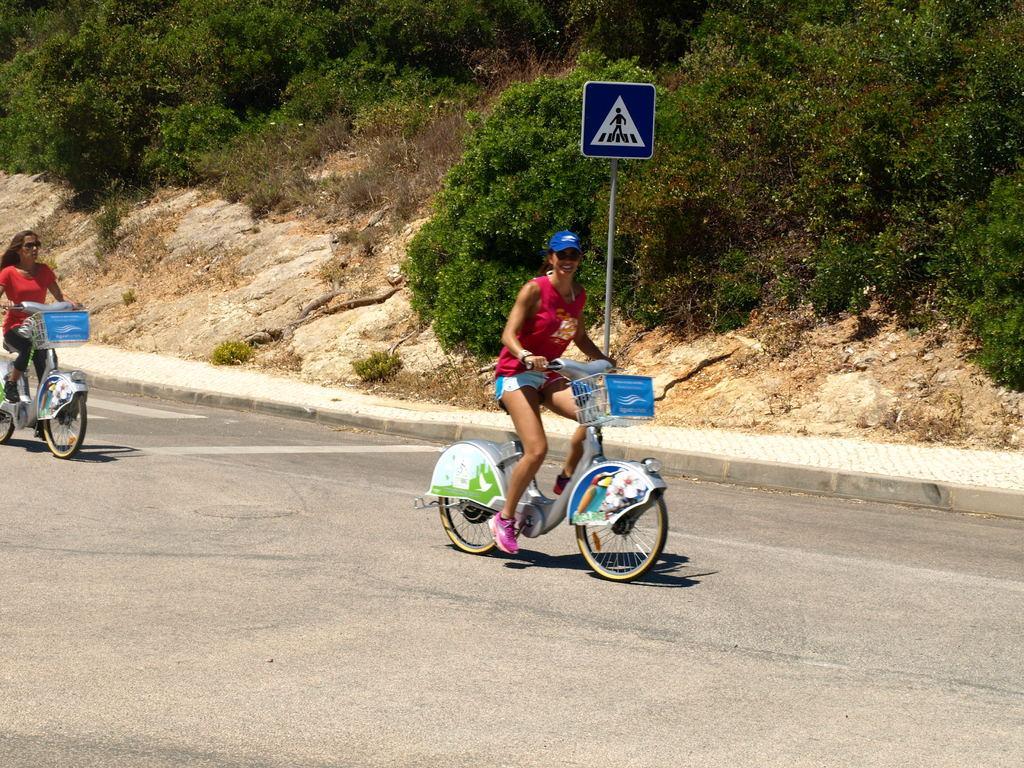Describe this image in one or two sentences. In this image I can see two people sitting on the bicycles. I can see the road. In the background, I can see the stones and the trees. 